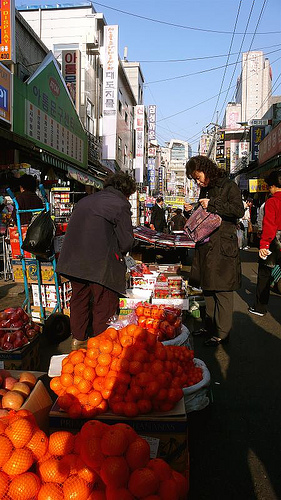Describe the interaction happening in the center of the market. In the center of the market, two people appear to be engaged in a lively exchange, possibly over the price or quality of fresh vegetables displayed on a stand. This bustling area shows the vibrant local commerce and cultural engagement typical of such markets. 